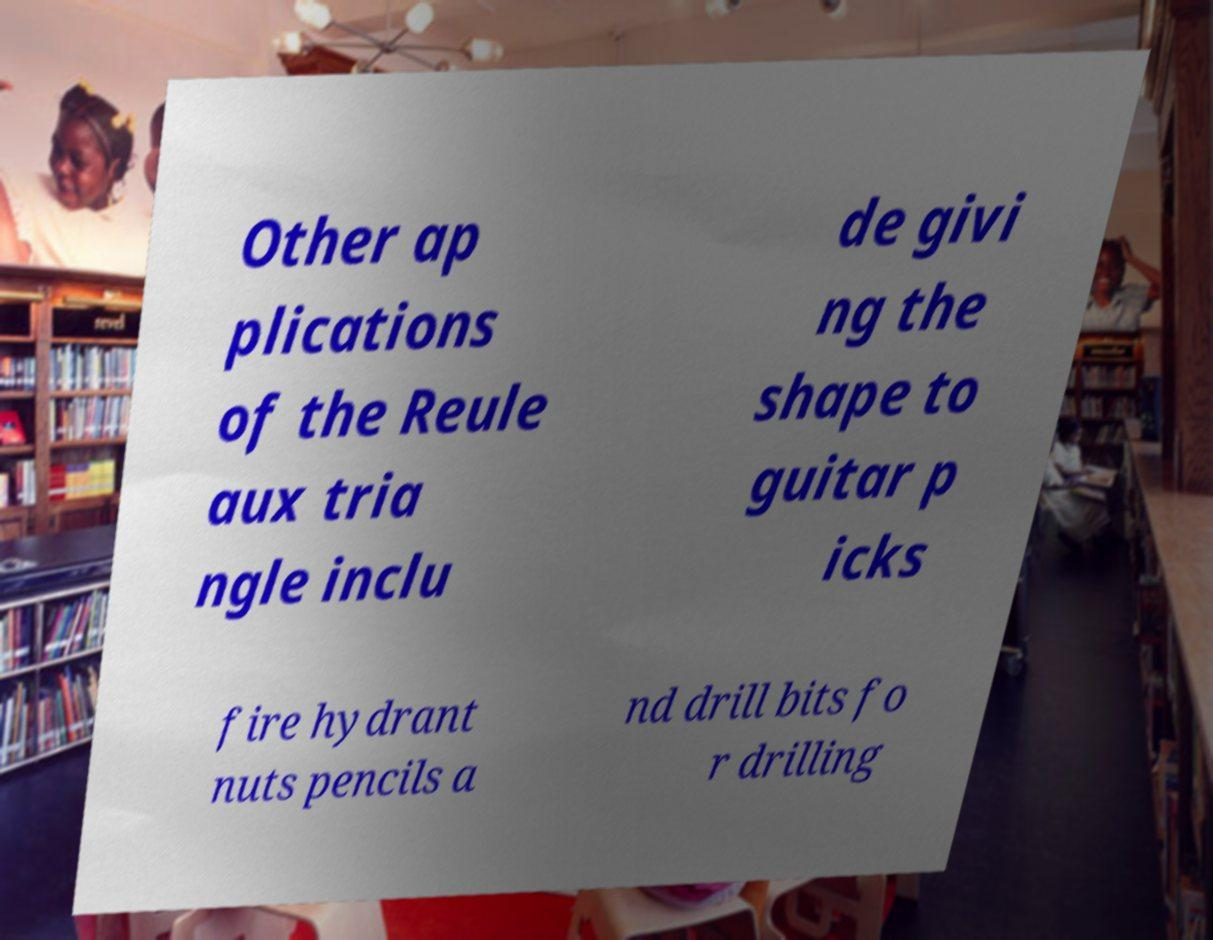Please read and relay the text visible in this image. What does it say? Other ap plications of the Reule aux tria ngle inclu de givi ng the shape to guitar p icks fire hydrant nuts pencils a nd drill bits fo r drilling 